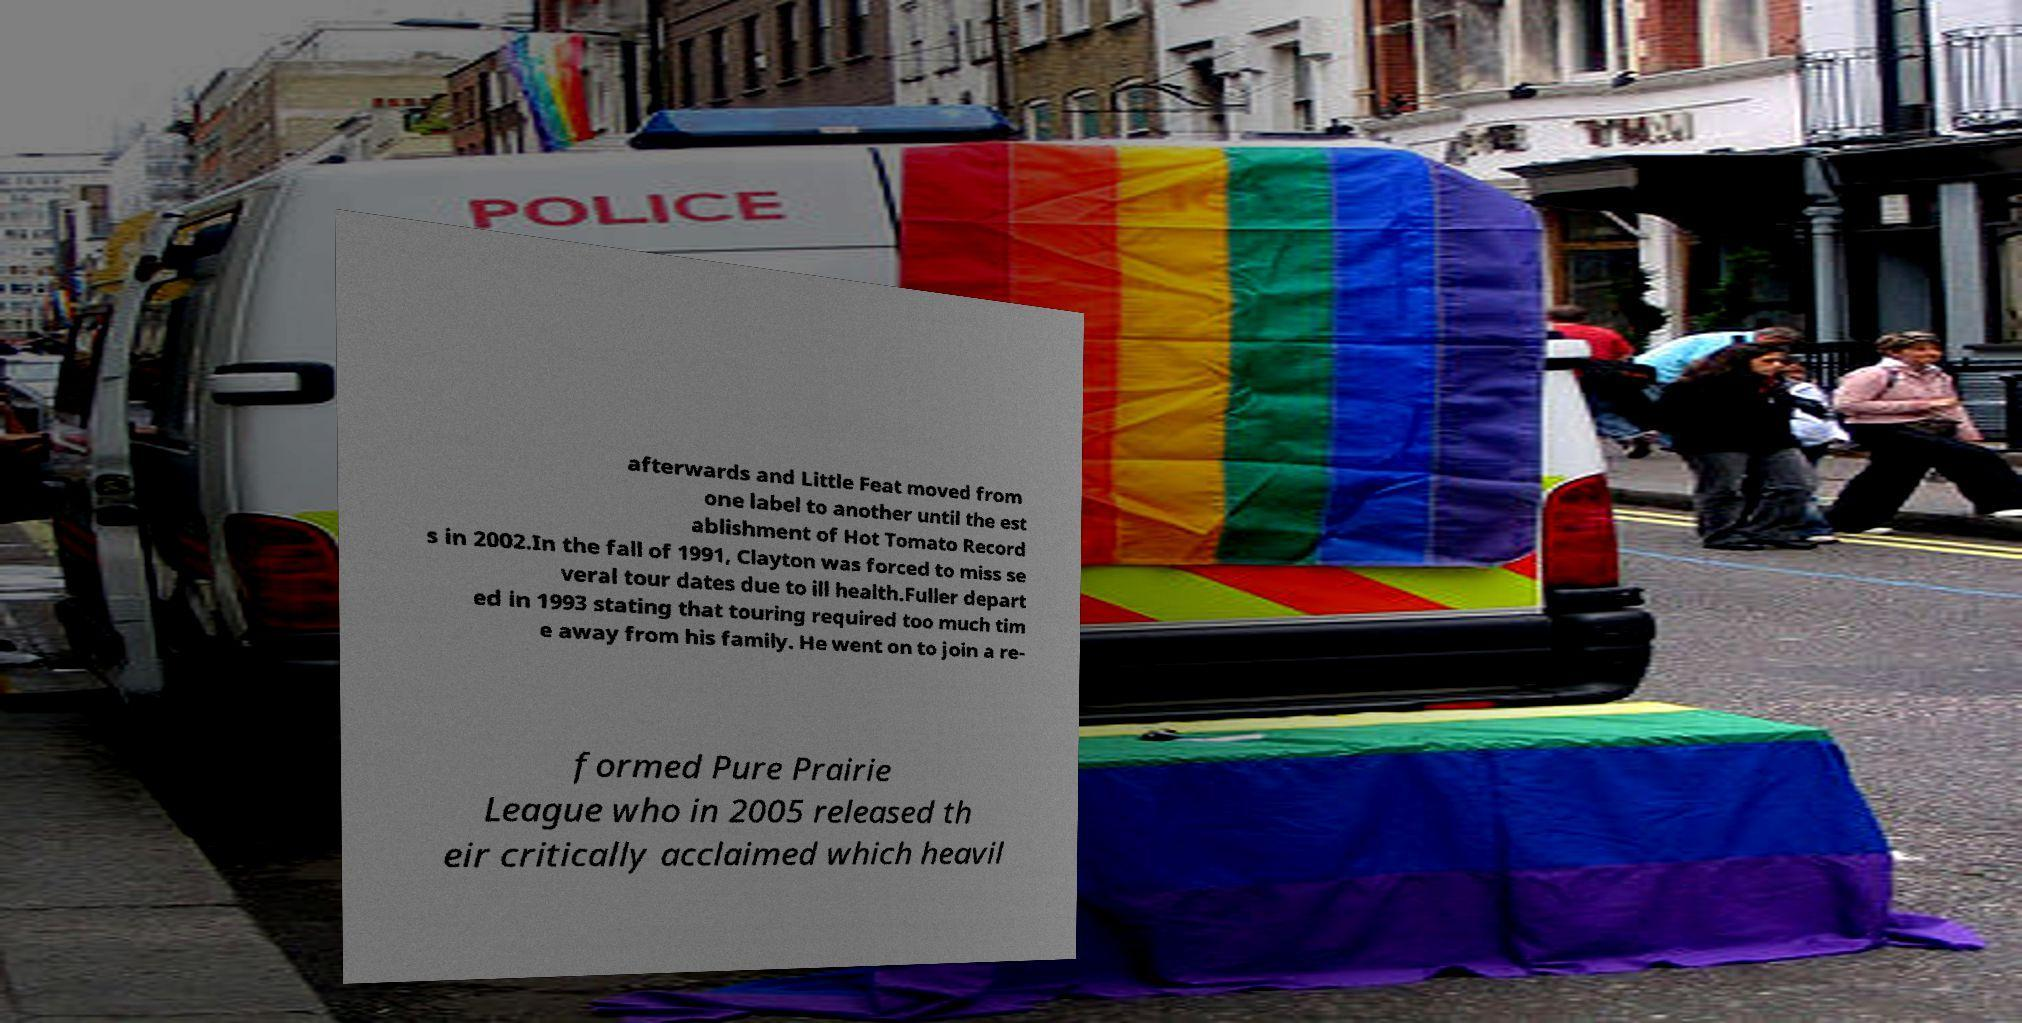What messages or text are displayed in this image? I need them in a readable, typed format. afterwards and Little Feat moved from one label to another until the est ablishment of Hot Tomato Record s in 2002.In the fall of 1991, Clayton was forced to miss se veral tour dates due to ill health.Fuller depart ed in 1993 stating that touring required too much tim e away from his family. He went on to join a re- formed Pure Prairie League who in 2005 released th eir critically acclaimed which heavil 